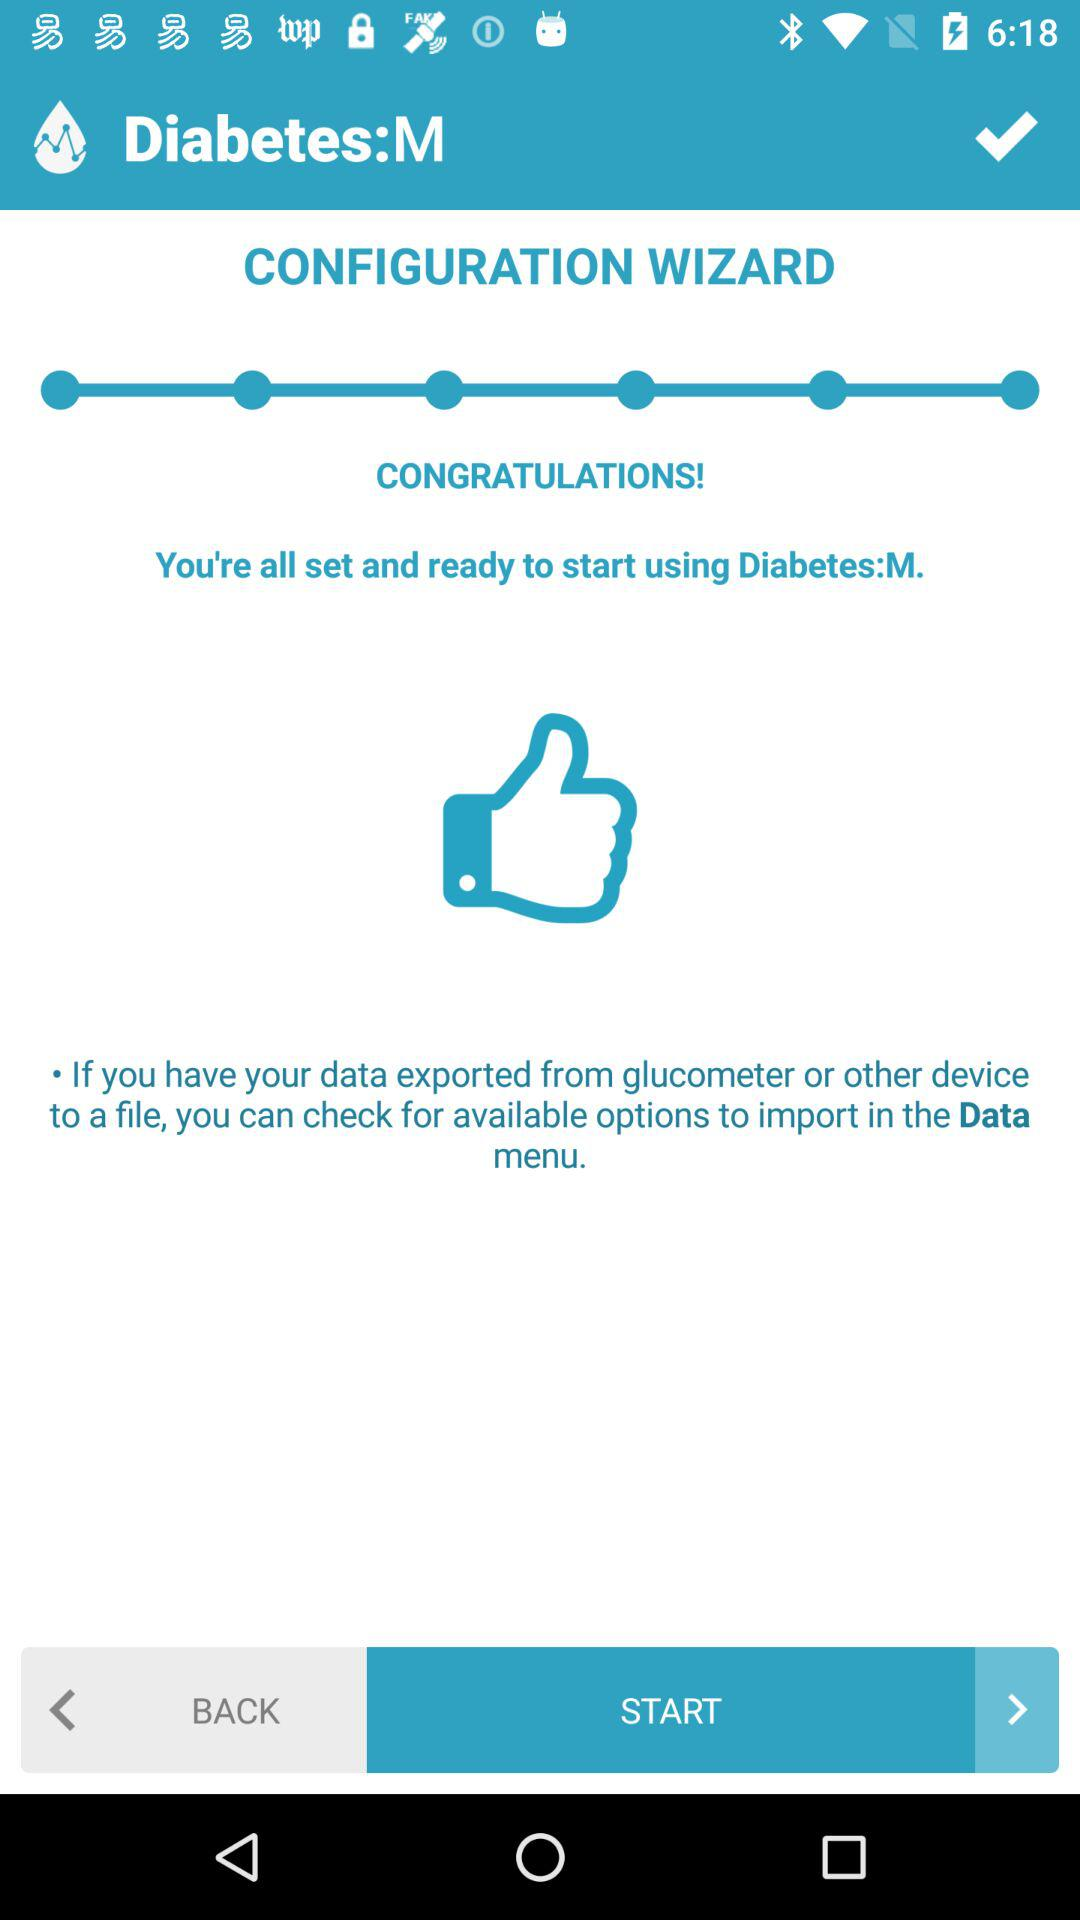Which option is selected?
When the provided information is insufficient, respond with <no answer>. <no answer> 